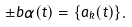<formula> <loc_0><loc_0><loc_500><loc_500>\pm b { \alpha } ( t ) = \{ \hat { a } _ { k } ( t ) \} .</formula> 